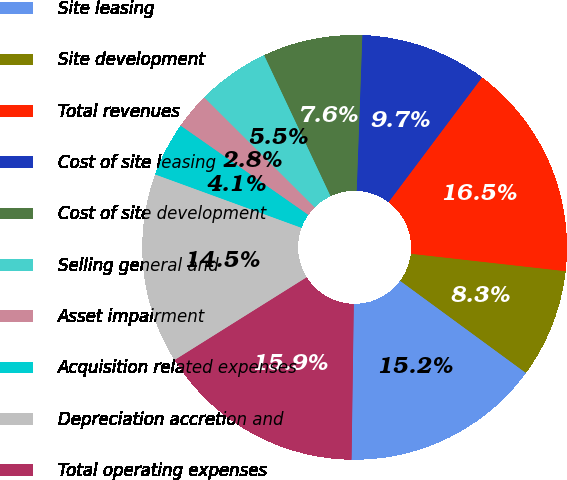<chart> <loc_0><loc_0><loc_500><loc_500><pie_chart><fcel>Site leasing<fcel>Site development<fcel>Total revenues<fcel>Cost of site leasing<fcel>Cost of site development<fcel>Selling general and<fcel>Asset impairment<fcel>Acquisition related expenses<fcel>Depreciation accretion and<fcel>Total operating expenses<nl><fcel>15.17%<fcel>8.28%<fcel>16.55%<fcel>9.66%<fcel>7.59%<fcel>5.52%<fcel>2.76%<fcel>4.14%<fcel>14.48%<fcel>15.86%<nl></chart> 